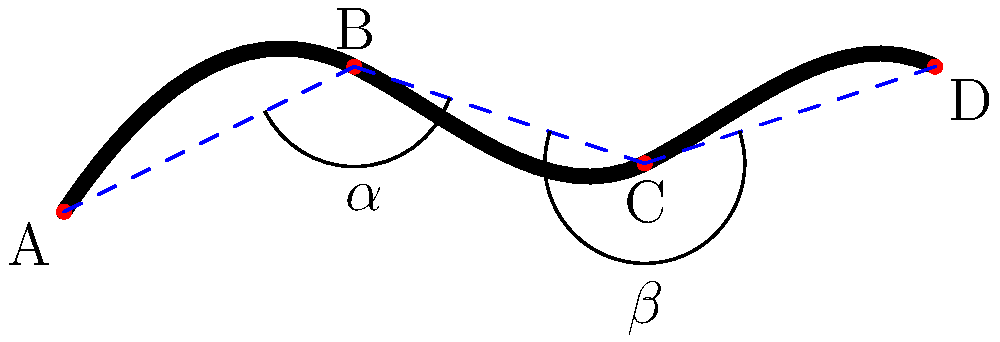In the given diagram of a coiled snake, analyze the angles formed by its body position. If angle $\alpha$ measures 150°, what is the measure of angle $\beta$? To solve this problem, let's follow these steps:

1. Observe that the snake's body forms a series of connected line segments (AB, BC, and CD).

2. Notice that these line segments create two angles: $\alpha$ and $\beta$.

3. Recall that when a line is drawn across two other lines, the alternate interior angles are equal. In this case, $\angle ABC$ and $\angle BCD$ are alternate interior angles.

4. Therefore, $\angle ABC + \angle BCD = 180°$ (they form a straight line).

5. We are given that $\alpha = 150°$.

6. $\beta$ is the supplement of $\alpha$, meaning:
   $\alpha + \beta = 180°$

7. Substitute the known value:
   $150° + \beta = 180°$

8. Solve for $\beta$:
   $\beta = 180° - 150° = 30°$

Thus, the measure of angle $\beta$ is 30°.
Answer: 30° 